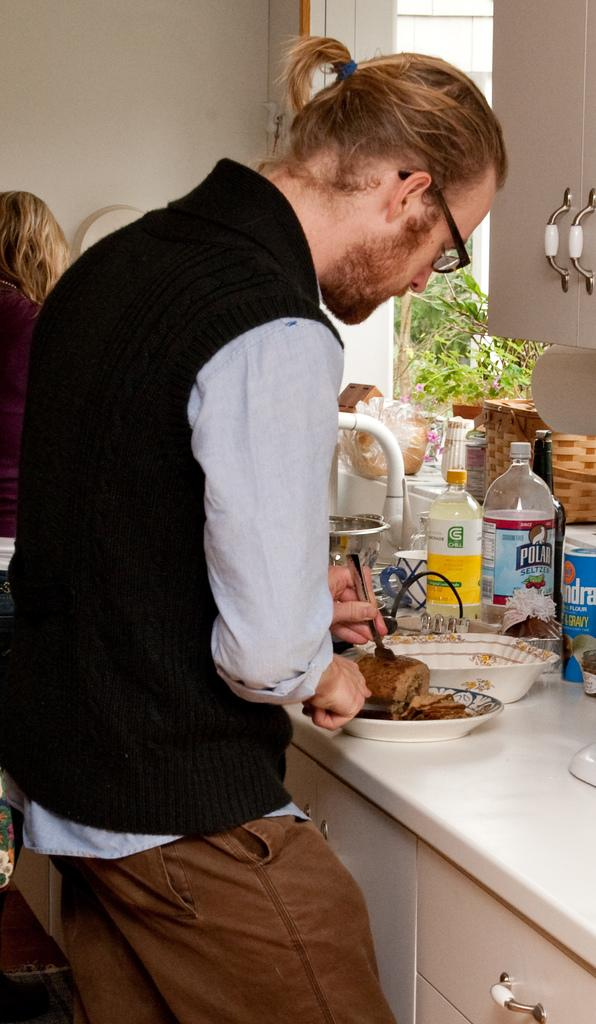<image>
Create a compact narrative representing the image presented. A man is preparing a dish and standing next to a Polar seltzer bottle. 